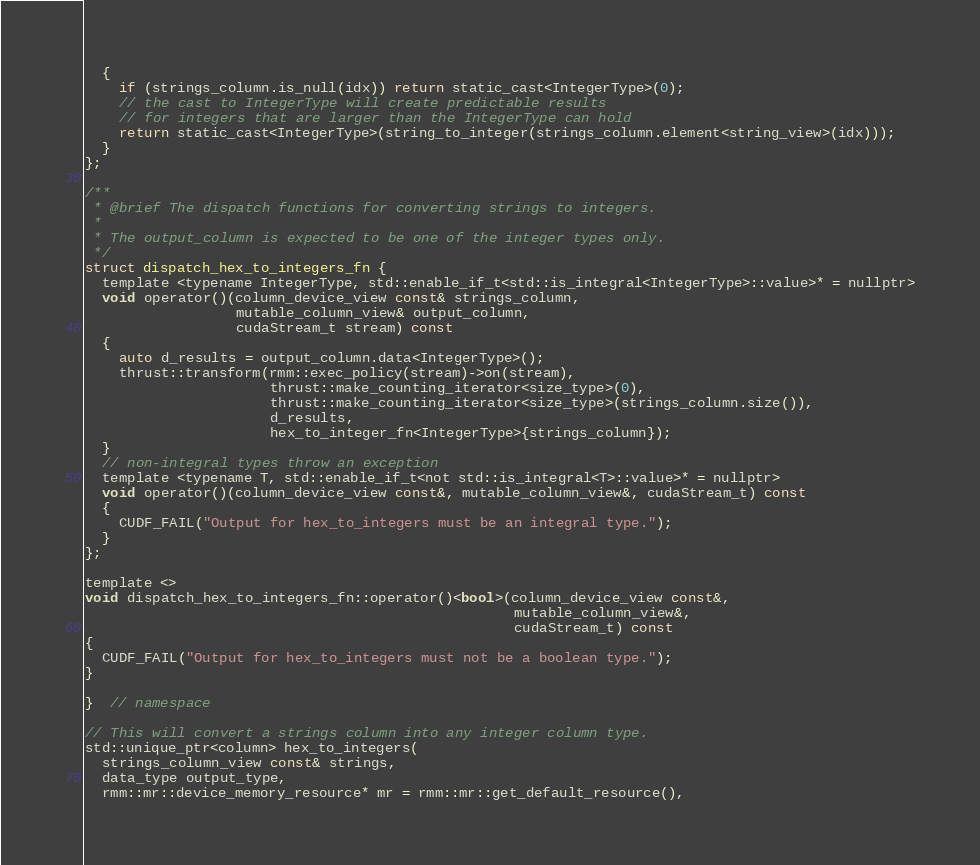<code> <loc_0><loc_0><loc_500><loc_500><_Cuda_>  {
    if (strings_column.is_null(idx)) return static_cast<IntegerType>(0);
    // the cast to IntegerType will create predictable results
    // for integers that are larger than the IntegerType can hold
    return static_cast<IntegerType>(string_to_integer(strings_column.element<string_view>(idx)));
  }
};

/**
 * @brief The dispatch functions for converting strings to integers.
 *
 * The output_column is expected to be one of the integer types only.
 */
struct dispatch_hex_to_integers_fn {
  template <typename IntegerType, std::enable_if_t<std::is_integral<IntegerType>::value>* = nullptr>
  void operator()(column_device_view const& strings_column,
                  mutable_column_view& output_column,
                  cudaStream_t stream) const
  {
    auto d_results = output_column.data<IntegerType>();
    thrust::transform(rmm::exec_policy(stream)->on(stream),
                      thrust::make_counting_iterator<size_type>(0),
                      thrust::make_counting_iterator<size_type>(strings_column.size()),
                      d_results,
                      hex_to_integer_fn<IntegerType>{strings_column});
  }
  // non-integral types throw an exception
  template <typename T, std::enable_if_t<not std::is_integral<T>::value>* = nullptr>
  void operator()(column_device_view const&, mutable_column_view&, cudaStream_t) const
  {
    CUDF_FAIL("Output for hex_to_integers must be an integral type.");
  }
};

template <>
void dispatch_hex_to_integers_fn::operator()<bool>(column_device_view const&,
                                                   mutable_column_view&,
                                                   cudaStream_t) const
{
  CUDF_FAIL("Output for hex_to_integers must not be a boolean type.");
}

}  // namespace

// This will convert a strings column into any integer column type.
std::unique_ptr<column> hex_to_integers(
  strings_column_view const& strings,
  data_type output_type,
  rmm::mr::device_memory_resource* mr = rmm::mr::get_default_resource(),</code> 